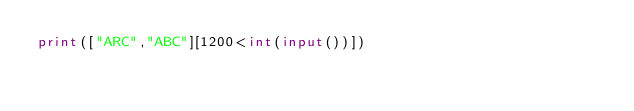<code> <loc_0><loc_0><loc_500><loc_500><_Python_>print(["ARC","ABC"][1200<int(input())])</code> 